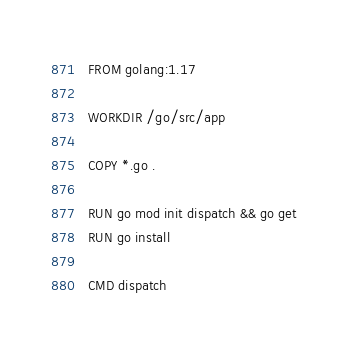Convert code to text. <code><loc_0><loc_0><loc_500><loc_500><_Dockerfile_>FROM golang:1.17

WORKDIR /go/src/app

COPY *.go .

RUN go mod init dispatch && go get
RUN go install

CMD dispatch
</code> 